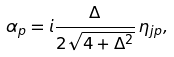Convert formula to latex. <formula><loc_0><loc_0><loc_500><loc_500>\alpha _ { p } = i \frac { \Delta } { 2 \sqrt { 4 + \Delta ^ { 2 } } } \, \eta _ { j p } ,</formula> 